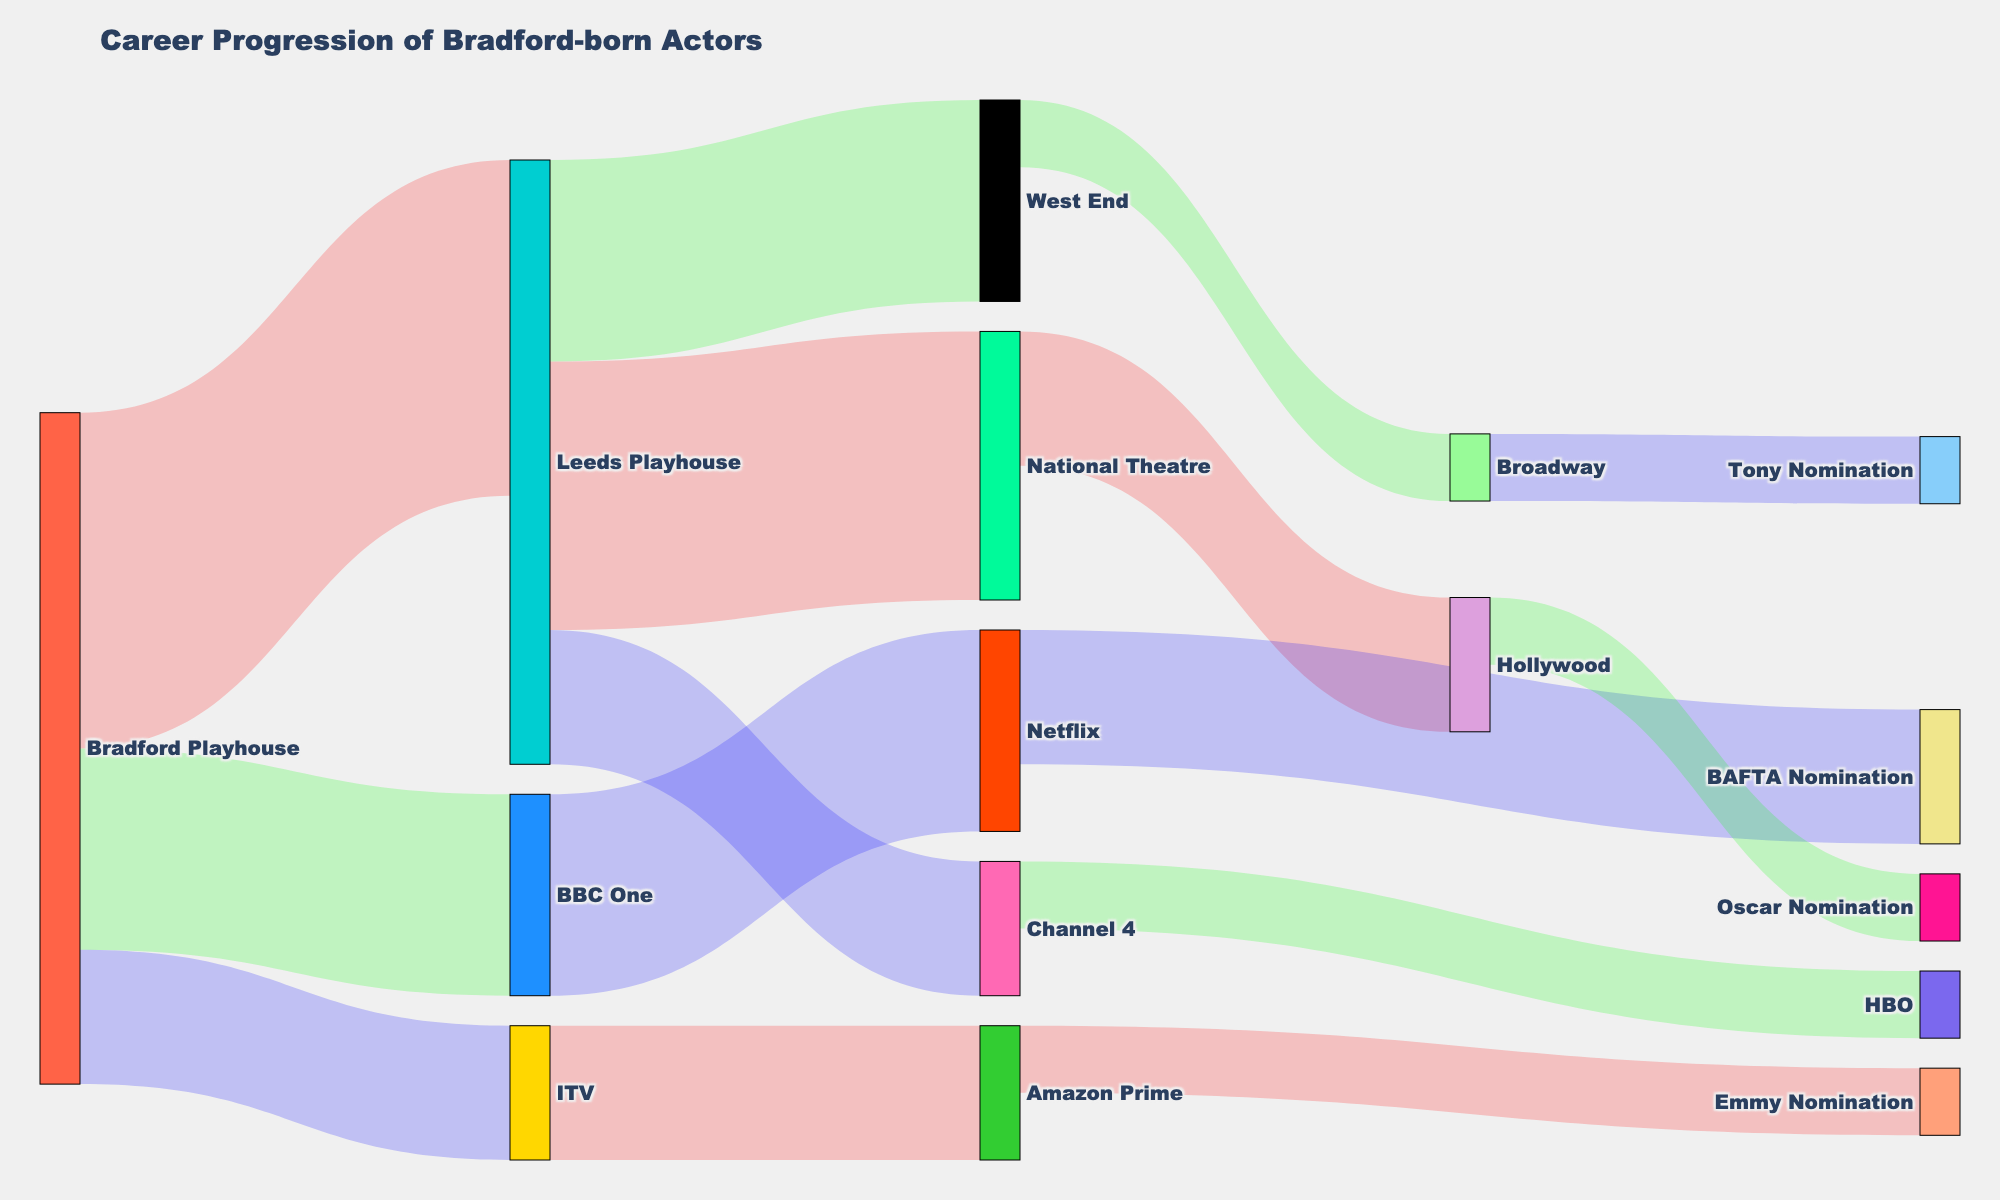How many actors progressed from the Bradford Playhouse to other levels? There are three target nodes linked to the Bradford Playhouse: Leeds Playhouse, BBC One, and ITV, with the values 5, 3, and 2 respectively. Summing these values gives 5 + 3 + 2 = 10 actors in total.
Answer: 10 Which pathway from Leeds Playhouse results in the highest number of actors? Leeds Playhouse links to National Theatre, West End, and Channel 4 with values 4, 3, and 2 respectively. The highest value is 4, corresponding to National Theatre.
Answer: National Theatre What is the total value of actors making it to Nomination levels through National Theatre? National Theatre feeds into Hollywood, which leads to Oscar Nomination with value 1. Thus, 2 actors reach Oscar Nomination through Hollywood via National Theatre.
Answer: 2 Which source to target link has the lowest flow value? Examining the 'Value' column, the lowest value is 1, seen between West End to Broadway, and Channel 4 to HBO.
Answer: West End to Broadway, Channel 4 to HBO How many actors went from the Leeds Playhouse to an eventual nomination? From Leeds Playhouse, actors move to: National Theatre (then Hollywood, Oscar Nomination), West End (then Broadway, Tony Nomination), and Channel 4 (no nomination link). The values are 4 and 3 respectively. Summing these gives 2 + 1 + 1 = 2 actors who achieved nominations from Leeds Playhouse.
Answer: 2 What percentage of actors from Bradford Playhouse advanced to BBC One? Out of a total of 10 actors from Bradford Playhouse, 3 went to BBC One. The percentage is (3/10) * 100 = 30%.
Answer: 30% What is the overall count of nomination titles mentioned? List the nominations: BAFTA Nomination, Emmy Nomination, Oscar Nomination, and Tony Nomination. This totals to 4 nomination titles.
Answer: 4 Which source node has contributed to the highest sum of actor progressions? Summing the values of each source: Bradford Playhouse (5+3+2=10), Leeds Playhouse (4+3+2=9), National Theatre (2), West End (1), BBC One (3), ITV (2), Channel 4 (1). Bradford Playhouse has the highest total of 10.
Answer: Bradford Playhouse Compare the progression rate of actors from ITV to Amazon Prime versus BBC One to Netflix. ITV to Amazon Prime has a value of 2, BBC One to Netflix has a value of 3. Comparing 2 versus 3, BBC One to Netflix has the higher rate.
Answer: BBC One to Netflix How many actors proceed from Netflix to receive BAFTA nominations? From the Sankey diagram, Netflix to BAFTA Nomination has a value of 2.
Answer: 2 